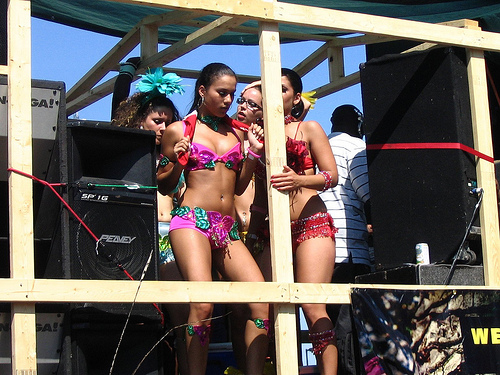<image>
Is there a top behind the speaker? No. The top is not behind the speaker. From this viewpoint, the top appears to be positioned elsewhere in the scene. Is the dancer on the stage? Yes. Looking at the image, I can see the dancer is positioned on top of the stage, with the stage providing support. Is the flower on the speaker? No. The flower is not positioned on the speaker. They may be near each other, but the flower is not supported by or resting on top of the speaker. Where is the girl in relation to the girl? Is it to the left of the girl? Yes. From this viewpoint, the girl is positioned to the left side relative to the girl. 